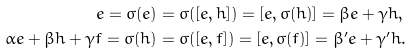<formula> <loc_0><loc_0><loc_500><loc_500>e = \sigma ( e ) & = \sigma ( [ e , h ] ) = [ e , \sigma ( h ) ] = \beta e + \gamma h , \\ \alpha e + \beta h + \gamma f = \sigma ( h ) & = \sigma ( [ e , f ] ) = [ e , \sigma ( f ) ] = \beta ^ { \prime } e + \gamma ^ { \prime } h .</formula> 